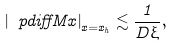<formula> <loc_0><loc_0><loc_500><loc_500>\left | \ p d i f f { M } { x } \right | _ { x = x _ { h } } \lesssim \frac { 1 } { D \xi } ,</formula> 